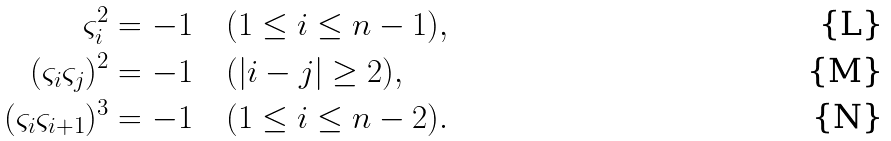<formula> <loc_0><loc_0><loc_500><loc_500>\varsigma _ { i } ^ { 2 } & = - 1 \quad ( 1 \leq i \leq n - 1 ) , \\ ( \varsigma _ { i } \varsigma _ { j } ) ^ { 2 } & = - 1 \quad ( | i - j | \geq 2 ) , \\ ( \varsigma _ { i } \varsigma _ { i + 1 } ) ^ { 3 } & = - 1 \quad ( 1 \leq i \leq n - 2 ) .</formula> 